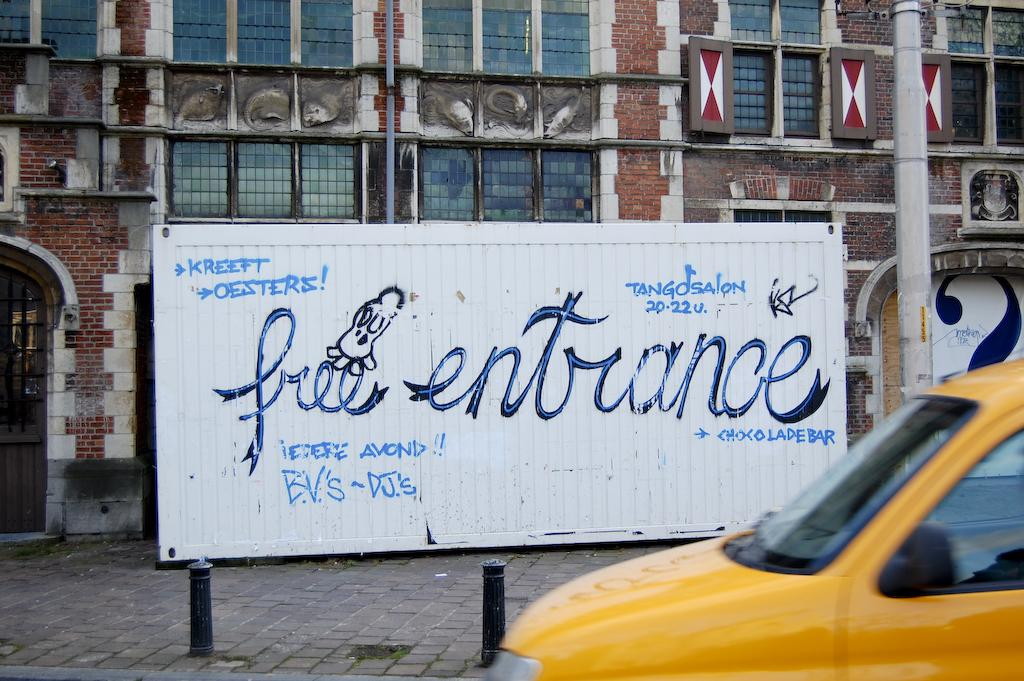<image>
Present a compact description of the photo's key features. A banner says free entrance in cursive writing. 